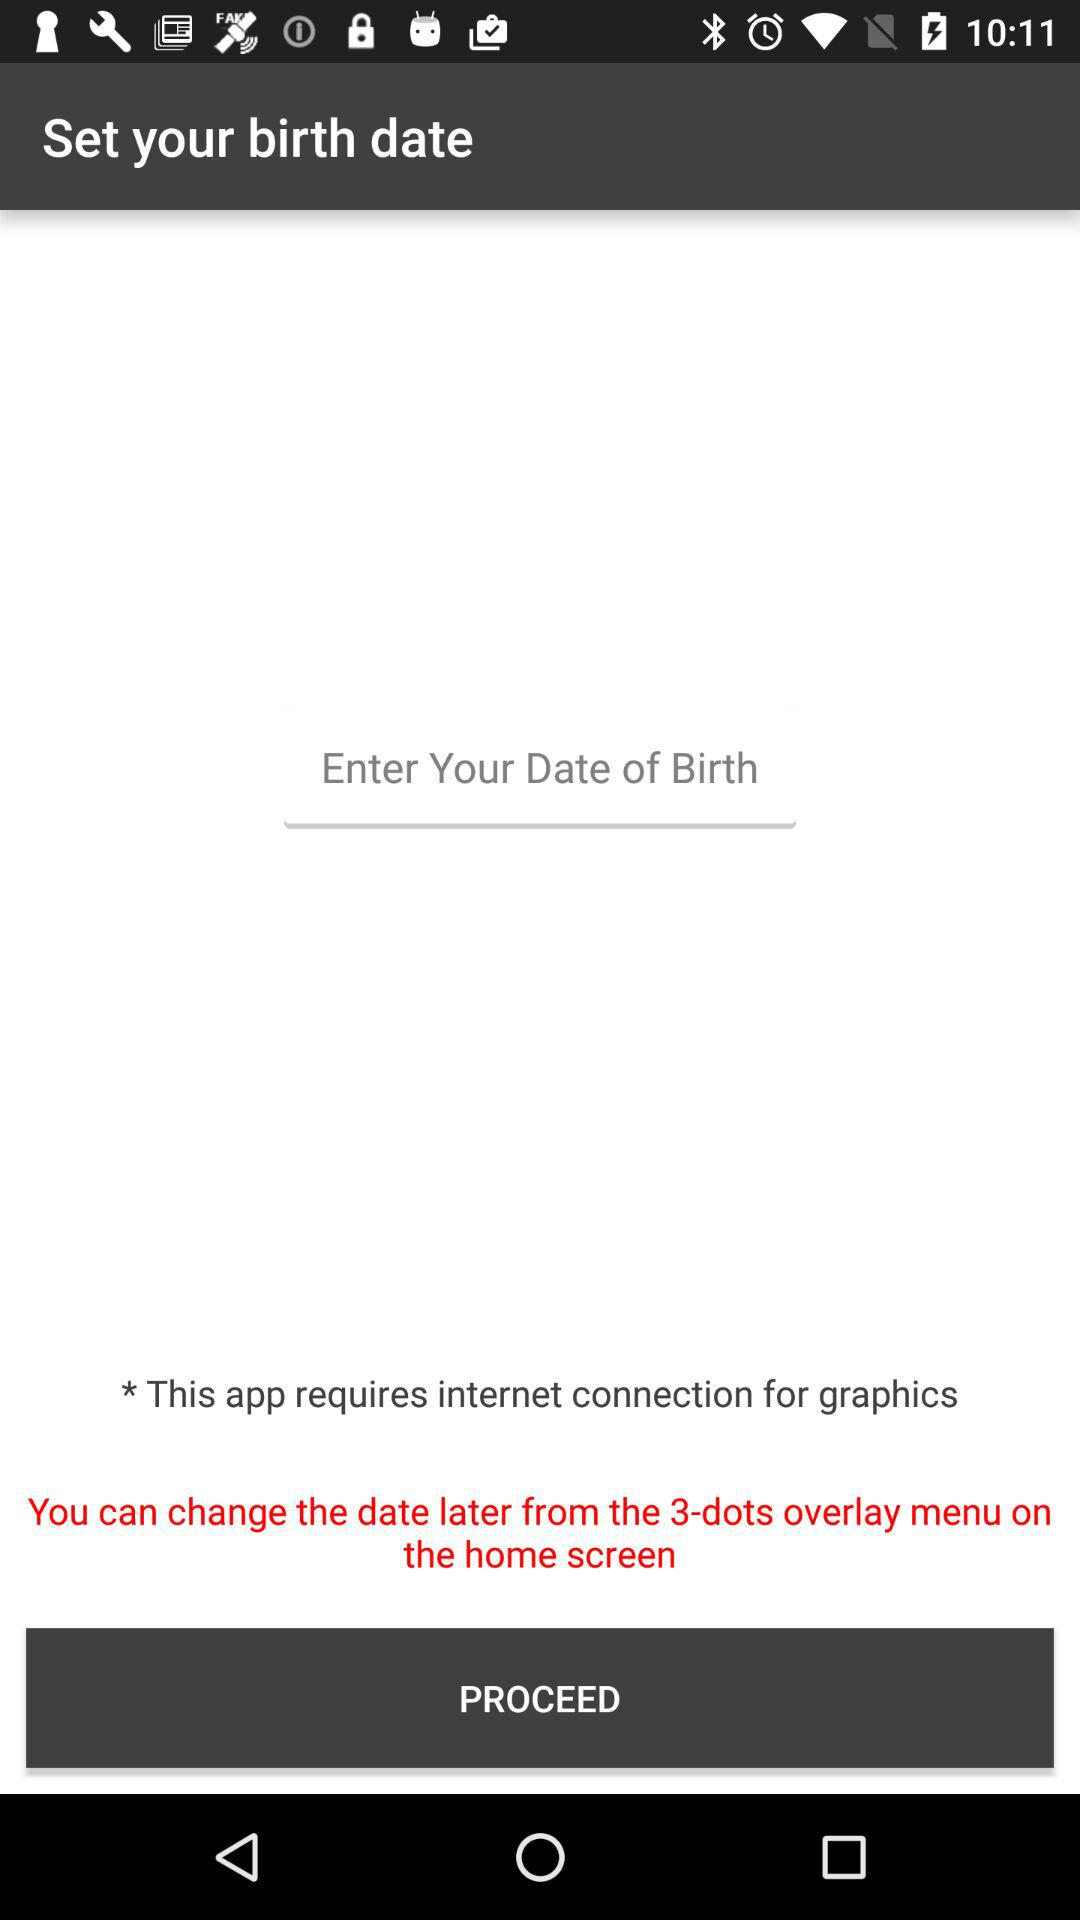From where can we change the date? You can change the date from the 3-dots overlay menu on the home screen. 